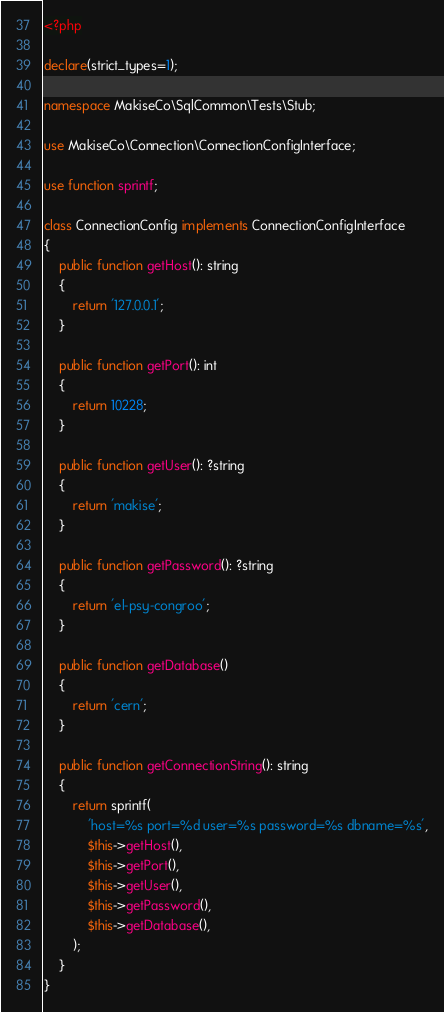<code> <loc_0><loc_0><loc_500><loc_500><_PHP_><?php

declare(strict_types=1);

namespace MakiseCo\SqlCommon\Tests\Stub;

use MakiseCo\Connection\ConnectionConfigInterface;

use function sprintf;

class ConnectionConfig implements ConnectionConfigInterface
{
    public function getHost(): string
    {
        return '127.0.0.1';
    }

    public function getPort(): int
    {
        return 10228;
    }

    public function getUser(): ?string
    {
        return 'makise';
    }

    public function getPassword(): ?string
    {
        return 'el-psy-congroo';
    }

    public function getDatabase()
    {
        return 'cern';
    }

    public function getConnectionString(): string
    {
        return sprintf(
            'host=%s port=%d user=%s password=%s dbname=%s',
            $this->getHost(),
            $this->getPort(),
            $this->getUser(),
            $this->getPassword(),
            $this->getDatabase(),
        );
    }
}
</code> 